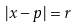Convert formula to latex. <formula><loc_0><loc_0><loc_500><loc_500>| x - p | = r</formula> 